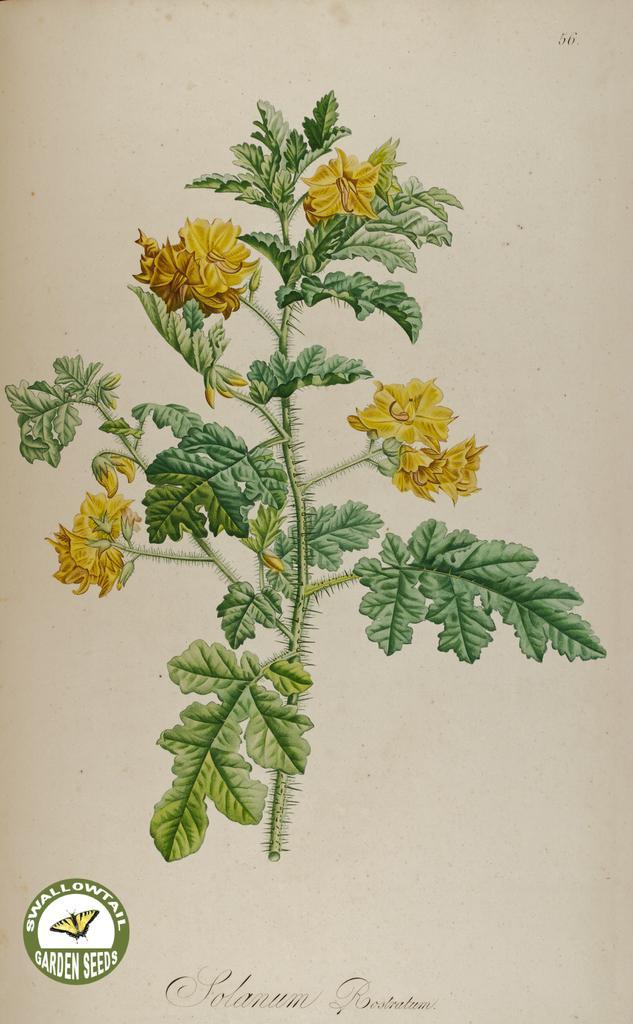Can you describe this image briefly? This is the picture of a painting. In this image there is a painting of a plant and there are yellow color flowers on the plant. At the bottom there is a text and logo. 